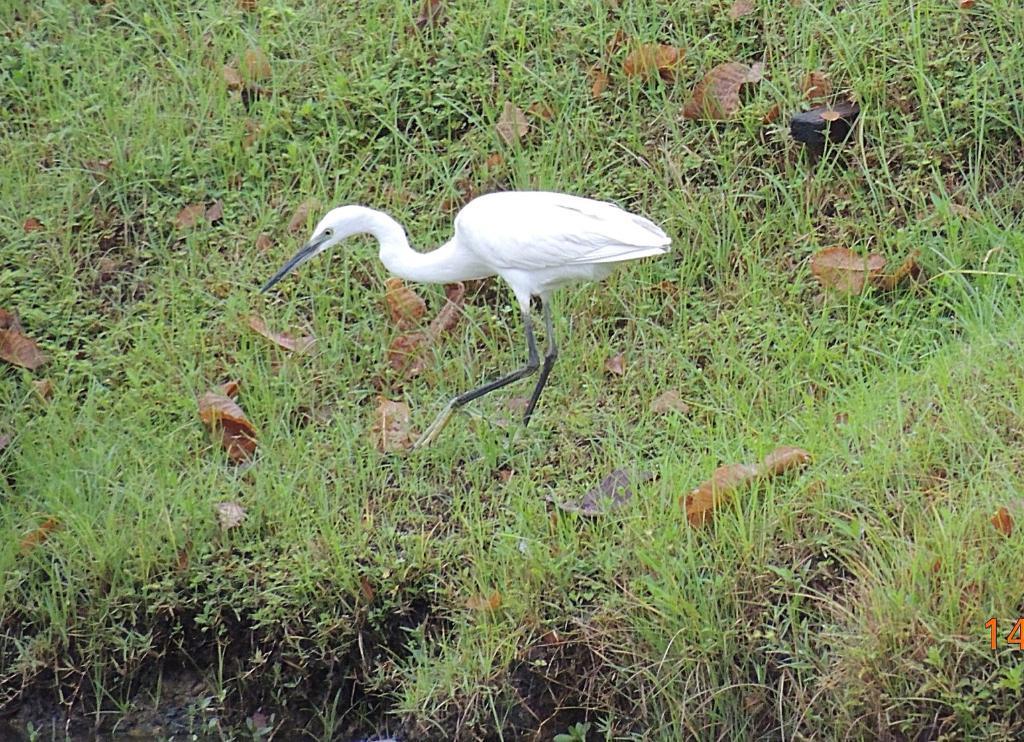Please provide a concise description of this image. Here I can see crane on the ground which is facing towards the left side. On the ground, I can see the grass and few leaves. 